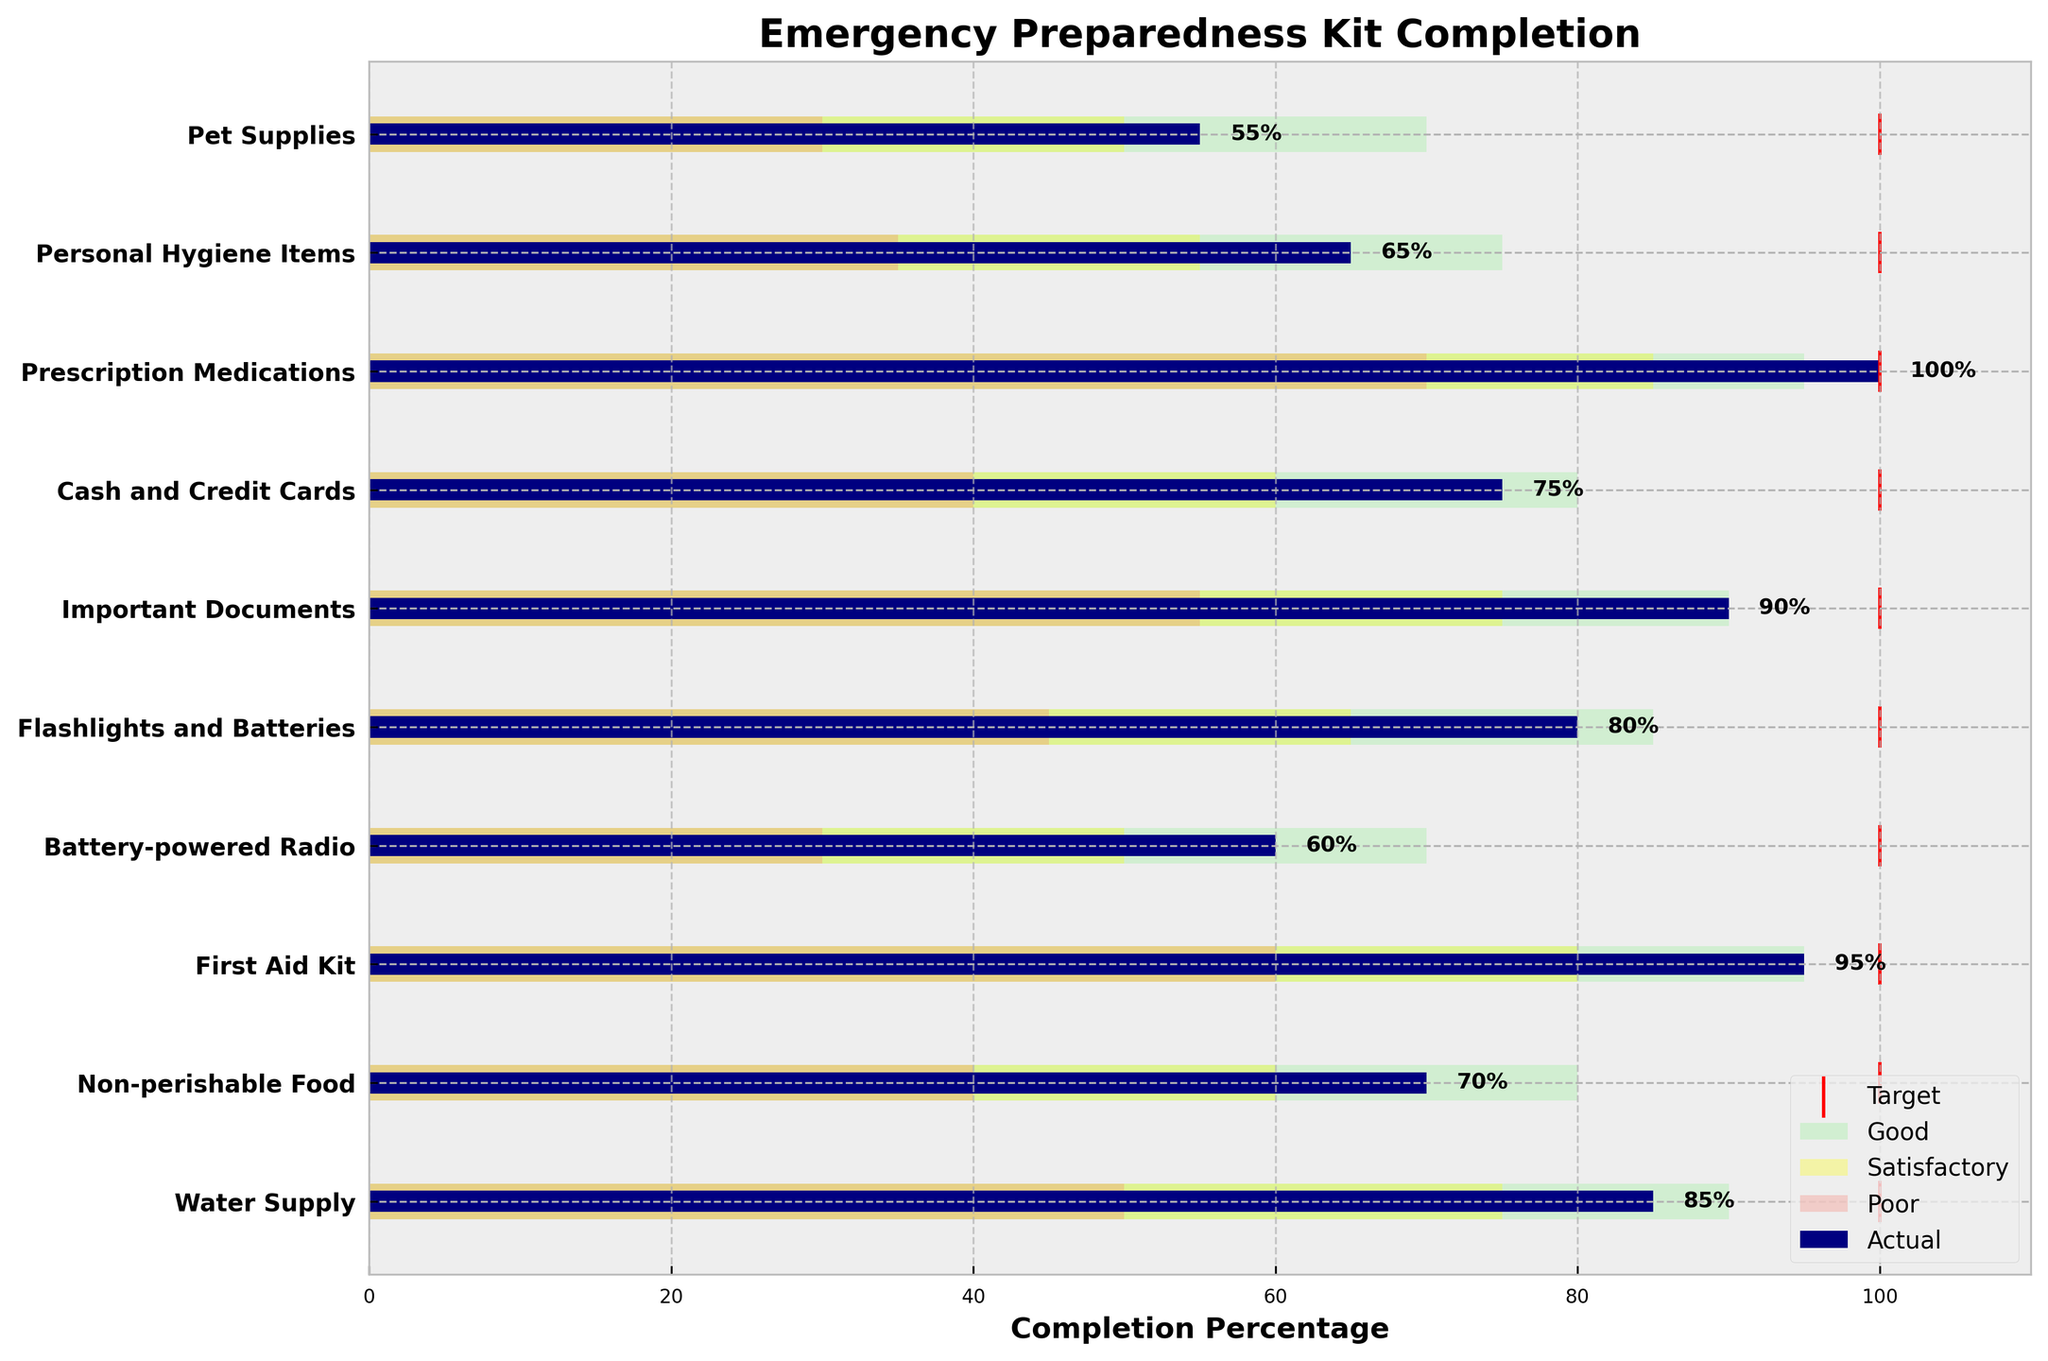What is the title of the chart? The title of the chart is typically placed at the top of the figure and is used to summarize the content or main point of the figure. In this case, the title reads "Emergency Preparedness Kit Completion".
Answer: Emergency Preparedness Kit Completion Which category has the highest actual completion percentage? When you examine the actual completion percentages in the chart, you can identify that Prescription Medications has an actual completion of 100%, which is the highest among all categories.
Answer: Prescription Medications Which categories have not met their target completion percentage? By comparing each category's actual completion percentage to its target, it can be observed that Water Supply, Non-perishable Food, Battery-powered Radio, Flashlights and Batteries, Cash and Credit Cards, Personal Hygiene Items, and Pet Supplies have not met their targets of 100%.
Answer: Water Supply, Non-perishable Food, Battery-powered Radio, Flashlights and Batteries, Cash and Credit Cards, Personal Hygiene Items, Pet Supplies In which category is the actual completion percentage just at the boundary of being rated as good? "Good" ranges are marked in light green. By looking at categories, Prescription Medications is at the boundary with 100% completion, which is also the highest among all, as 100% coincides with the upper limit of the good range.
Answer: Prescription Medications Which category has the poorest actual completion percentage? By looking at the actual completion percentage bars, Pet Supplies is the category with the lowest completion percentage of 55%.
Answer: Pet Supplies What is the difference in completion percentage between Water Supply and Flashlights and Batteries? To find the difference, subtract the actual completion percentage of Flashlights and Batteries (80%) from Water Supply's percentage (85%). So the difference is 85 - 80.
Answer: 5 Which categories have actual completion percentages rated as satisfactory? The "satisfactory" range is typically marked in yellow. Categories with actual completion percentages falling within this range are Non-perishable Food, Battery-powered Radio, Flashlights and Batteries, Cash and Credit Cards, and Personal Hygiene Items.
Answer: Non-perishable Food, Battery-powered Radio, Flashlights and Batteries, Cash and Credit Cards, Personal Hygiene Items How many categories have an actual completion percentage of 90% or more? By checking each category's actual completion percentage, the categories that are 90% or more are Water Supply, First Aid Kit, Important Documents, and Prescription Medications.
Answer: 4 Which category has an actual completion percentage closest to the satisfactory lower boundary? The satisfactory lower boundary varies by category. Pet Supplies has the lowest completion percentage (55%) among categories that barely cross into the satisfactory boundary.
Answer: Pet Supplies 